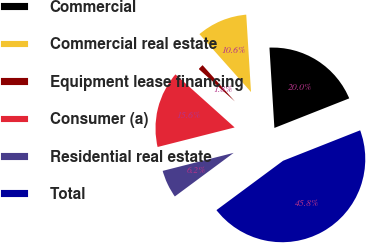<chart> <loc_0><loc_0><loc_500><loc_500><pie_chart><fcel>Commercial<fcel>Commercial real estate<fcel>Equipment lease financing<fcel>Consumer (a)<fcel>Residential real estate<fcel>Total<nl><fcel>19.99%<fcel>10.6%<fcel>1.79%<fcel>15.59%<fcel>6.19%<fcel>45.84%<nl></chart> 